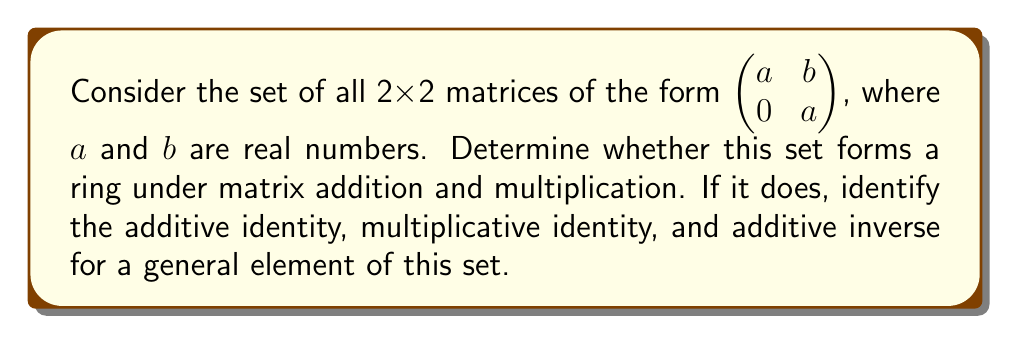Show me your answer to this math problem. To determine if this set forms a ring, we need to check if it satisfies all the ring axioms under matrix addition and multiplication:

1. Closure under addition:
Let $A = \begin{pmatrix} a_1 & b_1 \\ 0 & a_1 \end{pmatrix}$ and $B = \begin{pmatrix} a_2 & b_2 \\ 0 & a_2 \end{pmatrix}$
$A + B = \begin{pmatrix} a_1+a_2 & b_1+b_2 \\ 0 & a_1+a_2 \end{pmatrix}$
This is of the same form, so closure under addition holds.

2. Associativity of addition:
Matrix addition is always associative, so this holds.

3. Additive identity:
The zero matrix $\begin{pmatrix} 0 & 0 \\ 0 & 0 \end{pmatrix}$ is in the set and serves as the additive identity.

4. Additive inverse:
For $A = \begin{pmatrix} a & b \\ 0 & a \end{pmatrix}$, its additive inverse is $-A = \begin{pmatrix} -a & -b \\ 0 & -a \end{pmatrix}$, which is also in the set.

5. Commutativity of addition:
Matrix addition is always commutative, so this holds.

6. Closure under multiplication:
$A \cdot B = \begin{pmatrix} a_1 & b_1 \\ 0 & a_1 \end{pmatrix} \cdot \begin{pmatrix} a_2 & b_2 \\ 0 & a_2 \end{pmatrix} = \begin{pmatrix} a_1a_2 & a_1b_2+b_1a_2 \\ 0 & a_1a_2 \end{pmatrix}$
This is of the same form, so closure under multiplication holds.

7. Associativity of multiplication:
Matrix multiplication is always associative, so this holds.

8. Multiplicative identity:
The identity matrix $\begin{pmatrix} 1 & 0 \\ 0 & 1 \end{pmatrix}$ is in the set and serves as the multiplicative identity.

9. Distributivity:
Matrix multiplication always distributes over addition, so this holds.

Since all ring axioms are satisfied, this set forms a ring under matrix addition and multiplication.

Additive identity: $\begin{pmatrix} 0 & 0 \\ 0 & 0 \end{pmatrix}$
Multiplicative identity: $\begin{pmatrix} 1 & 0 \\ 0 & 1 \end{pmatrix}$
Additive inverse of $\begin{pmatrix} a & b \\ 0 & a \end{pmatrix}$: $\begin{pmatrix} -a & -b \\ 0 & -a \end{pmatrix}$
Answer: Yes, the given set of matrices forms a ring under matrix addition and multiplication. The additive identity is $\begin{pmatrix} 0 & 0 \\ 0 & 0 \end{pmatrix}$, the multiplicative identity is $\begin{pmatrix} 1 & 0 \\ 0 & 1 \end{pmatrix}$, and the additive inverse of a general element $\begin{pmatrix} a & b \\ 0 & a \end{pmatrix}$ is $\begin{pmatrix} -a & -b \\ 0 & -a \end{pmatrix}$. 